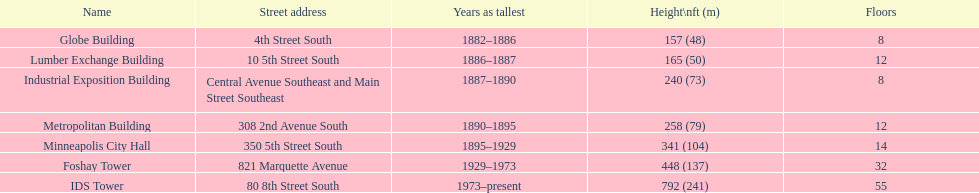Can you compare the heights of the metropolitan building and the lumber exchange building? Metropolitan Building. 